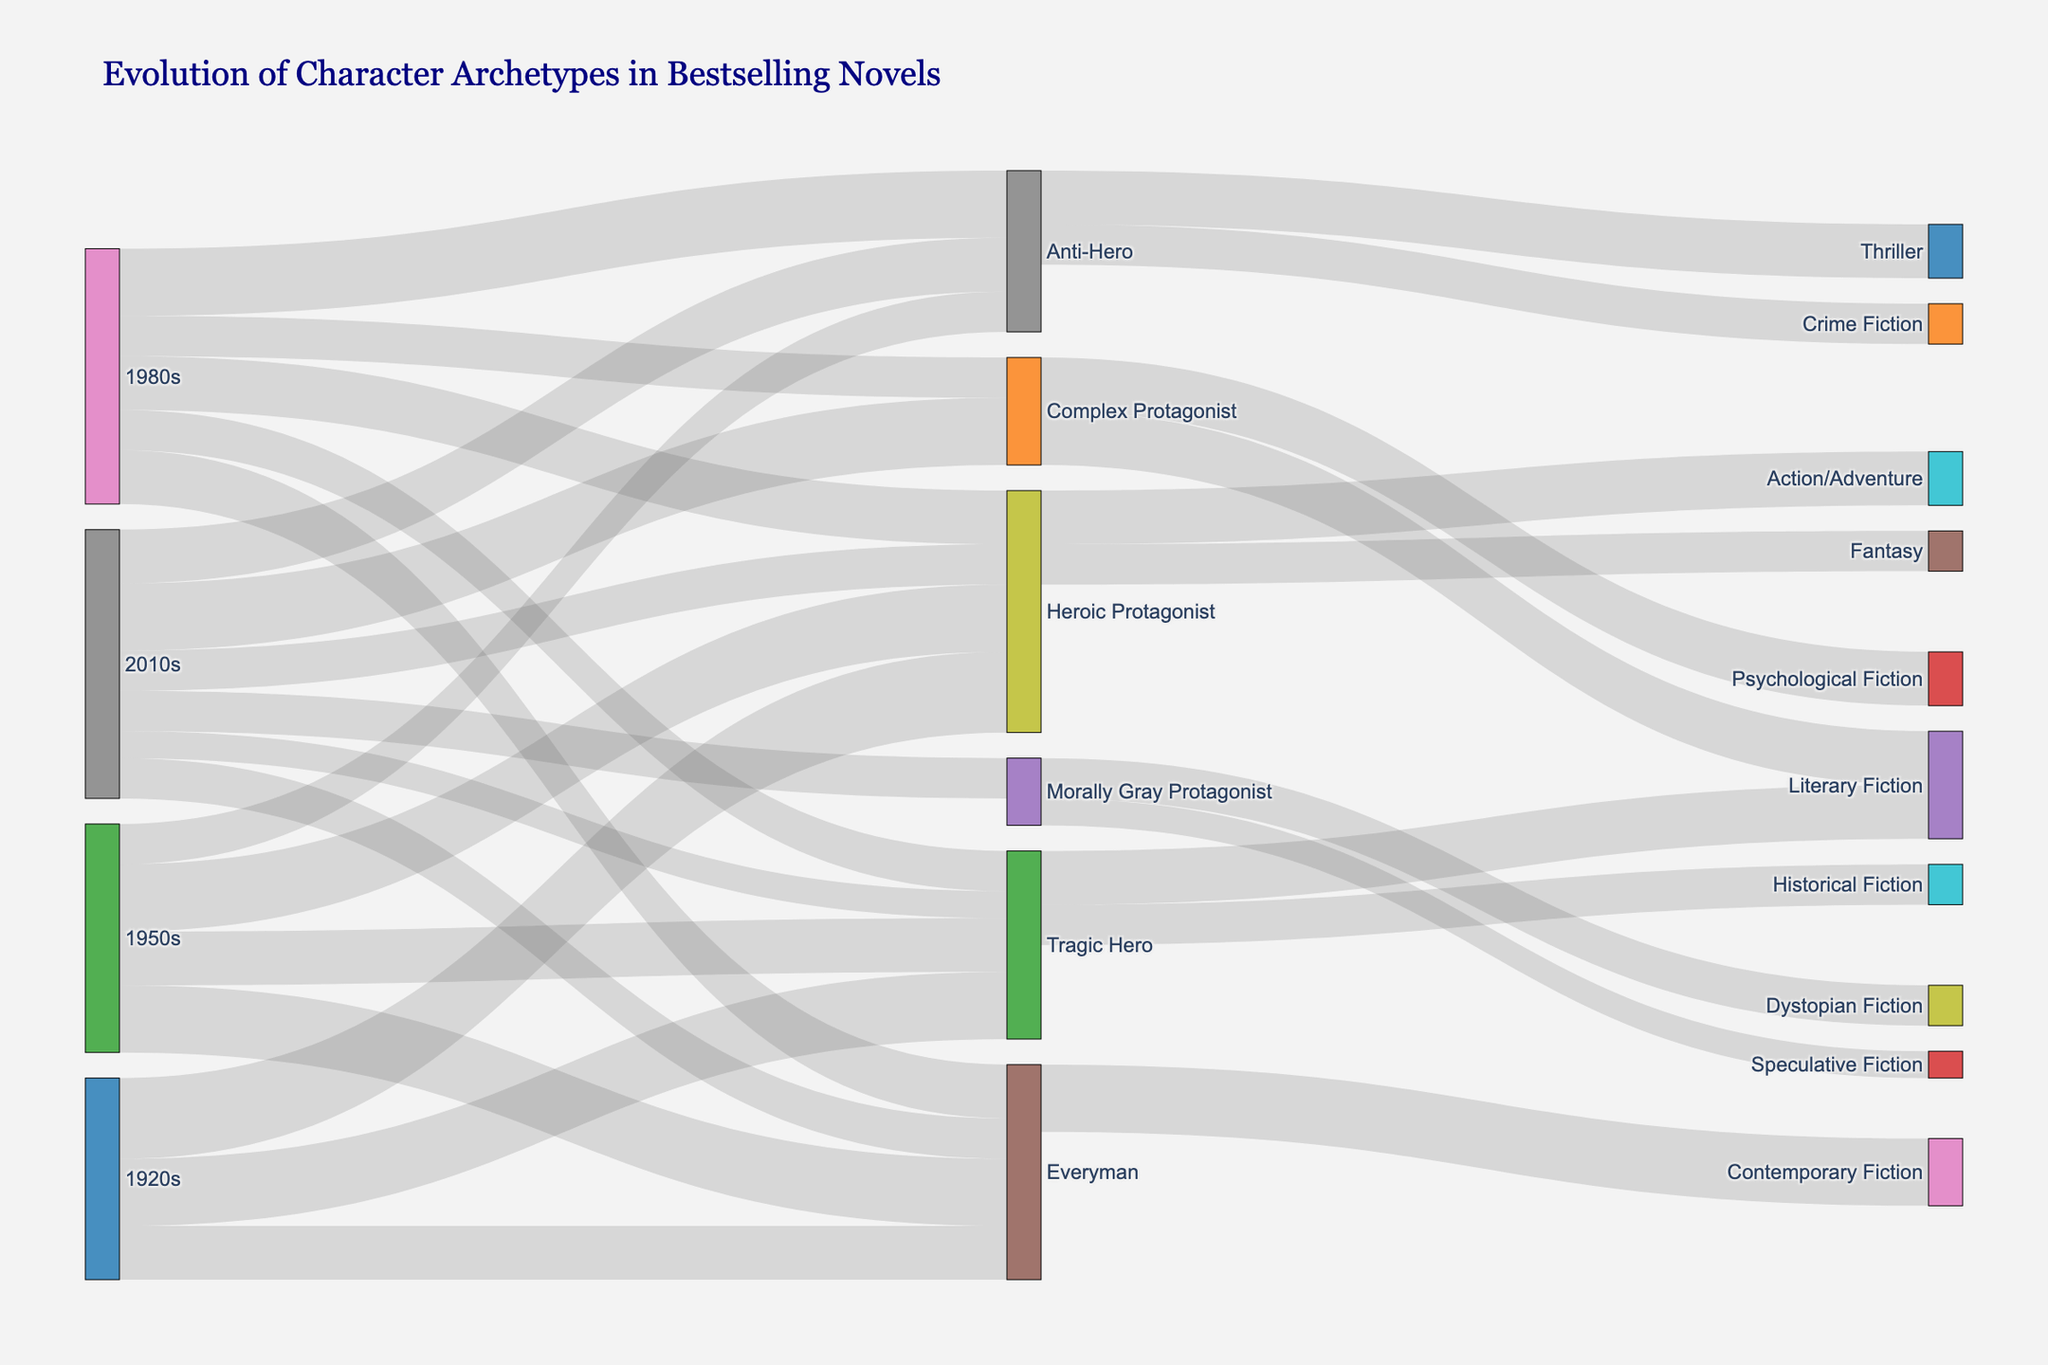Which decade introduces the most new character archetypes? The 1980s introduce the most new character archetypes. The archetypes Anti-Hero and Complex Protagonist both appear first in the 1980s.
Answer: 1980s Which character archetype appears most consistently across all decades? The Heroic Protagonist appears in every decade from the 1920s to the 2010s.
Answer: Heroic Protagonist How many archetypes are directly linked to the Everyman archetype? Counting all the direct links from the Everyman archetype to the years 1920s, 1950s, 1980s, and 2010s in the chart, there are four archetypes directly linked.
Answer: 4 Which genre does the Everyman archetype mostly evolve into? The Everyman archetype mainly evolves into Contemporary Fiction.
Answer: Contemporary Fiction Compare the evolution of the Heroic Protagonist and Anti-Hero archetypes in terms of the total value over the decades. Summing the Heroic Protagonist values across all decades (30 + 25 + 20 + 15 = 90) and the Anti-Hero (15 + 25 + 20 = 60), the Heroic Protagonist has a higher total value.
Answer: Heroic Protagonist Which archetype in the 2010s has the highest value? The Complex Protagonist archetype has the highest value in the 2010s (25).
Answer: Complex Protagonist How many different genres do the archetypes in the 2010s evolve into? Reviewing the final links, archetypes in the 2010s evolve into six different genres: Action/Adventure, Fantasy, Literary Fiction, Psychological Fiction, Dystopian Fiction, and Speculative Fiction.
Answer: 6 What's the total number of character archetype values in the 1950s? Summing all the archetype values in the 1950s: Heroic Protagonist (25), Tragic Hero (20), Everyman (25), Anti-Hero (15) gives: 25 + 20 + 25 + 15 = 85.
Answer: 85 Find the most prevalent genre for Complex Protagonists and provide its value. Complex Protagonists evolve into Literary Fiction and Psychological Fiction equally with a value of 20 each.
Answer: Literary Fiction, Psychological Fiction Which decade shows a decline in the value of Heroic Protagonist archetypes compared to the previous one? The 1980s show a decline (value 20) compared to the 1950s (value 25), and the 2010s show a further decline (value 15) compared to the 1980s.
Answer: 1980s and 2010s 